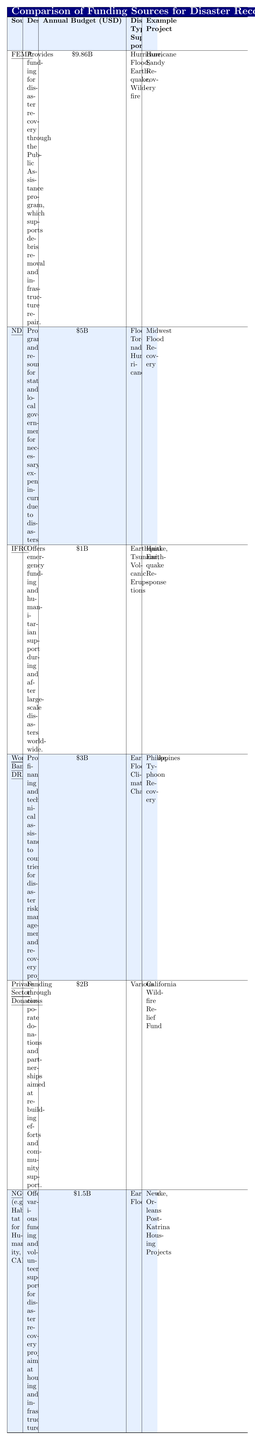What is the annual budget for FEMA? The table specifies that FEMA has an annual budget of \$9.86 billion, listed in the corresponding column for annual budgets.
Answer: \$9.86 billion Which funding source supports the highest number of disaster types? By reviewing the "Disaster Types Supported" column, FEMA supports four types: hurricane, flood, earthquake, and wildfire, which is the highest among the listed sources.
Answer: FEMA What is the total annual budget of the National Disaster Relief Fund (NDRF) and the World Bank Disaster Risk Management combined? The NDRF has an annual budget of \$5 billion and the World Bank DRM has \$3 billion. Adding these gives \$5B + \$3B = \$8B.
Answer: \$8 billion Does the International Federation of Red Cross and Red Crescent Societies (IFRC) support floods as a disaster type? In the "Disaster Types Supported" column, the IFRC supports earthquakes, tsunamis, and volcanic eruptions, but not floods. Thus, it does not support floods.
Answer: No What is the average annual budget across all funding sources listed in the table? To calculate the average, first sum the annual budgets: \$9.86B + \$5B + \$1B + \$3B + \$2B + \$1.5B = \$22.36B. Then divide by the number of sources (6): \$22.36B / 6 = \$3.727B (approximately).
Answer: \$3.73 billion Which source has the smallest budget? The smallest budget is for the International Federation of Red Cross and Red Crescent Societies (IFRC), which has an annual budget of \$1 billion.
Answer: IFRC How many funding sources specifically support earthquakes? Upon examining the "Disaster Types Supported" section, FEMA, IFRC, World Bank DRM, and NGOs support earthquakes, totaling four sources.
Answer: 4 What is the difference in annual budget between FEMA and Private Sector Donations? FEMA's budget is \$9.86 billion and Private Sector Donations is \$2 billion. The difference is calculated as \$9.86B - \$2B = \$7.86B.
Answer: \$7.86 billion Which funding source supports the disaster type "tornado"? The National Disaster Relief Fund (NDRF) is the only funding source that supports tornadoes according to the "Disaster Types Supported" column.
Answer: NDRF Is the description of NGOs (e.g., Habitat for Humanity, CARE) related to housing and infrastructure? The table clearly states that NGOs provide funding and volunteer support for projects aimed at housing and infrastructure, confirming their focus on these areas.
Answer: Yes Which funding source has an example project related to hurricane recovery? The example project linked to hurricane recovery is "Hurricane Sandy Recovery," which is associated with FEMA, according to the table.
Answer: FEMA 